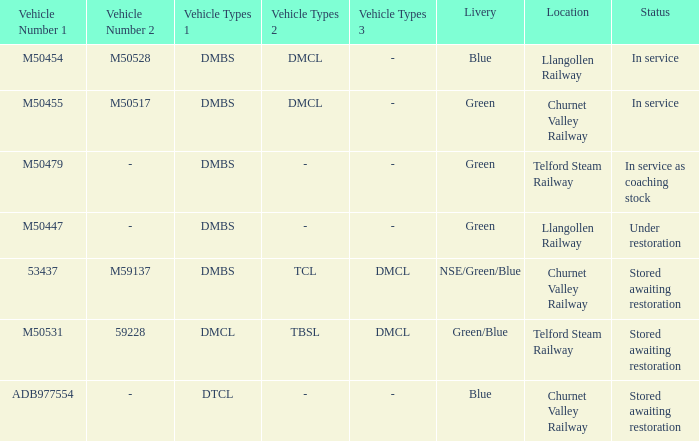What type of livery is being used as coaching stock in service? Green. 